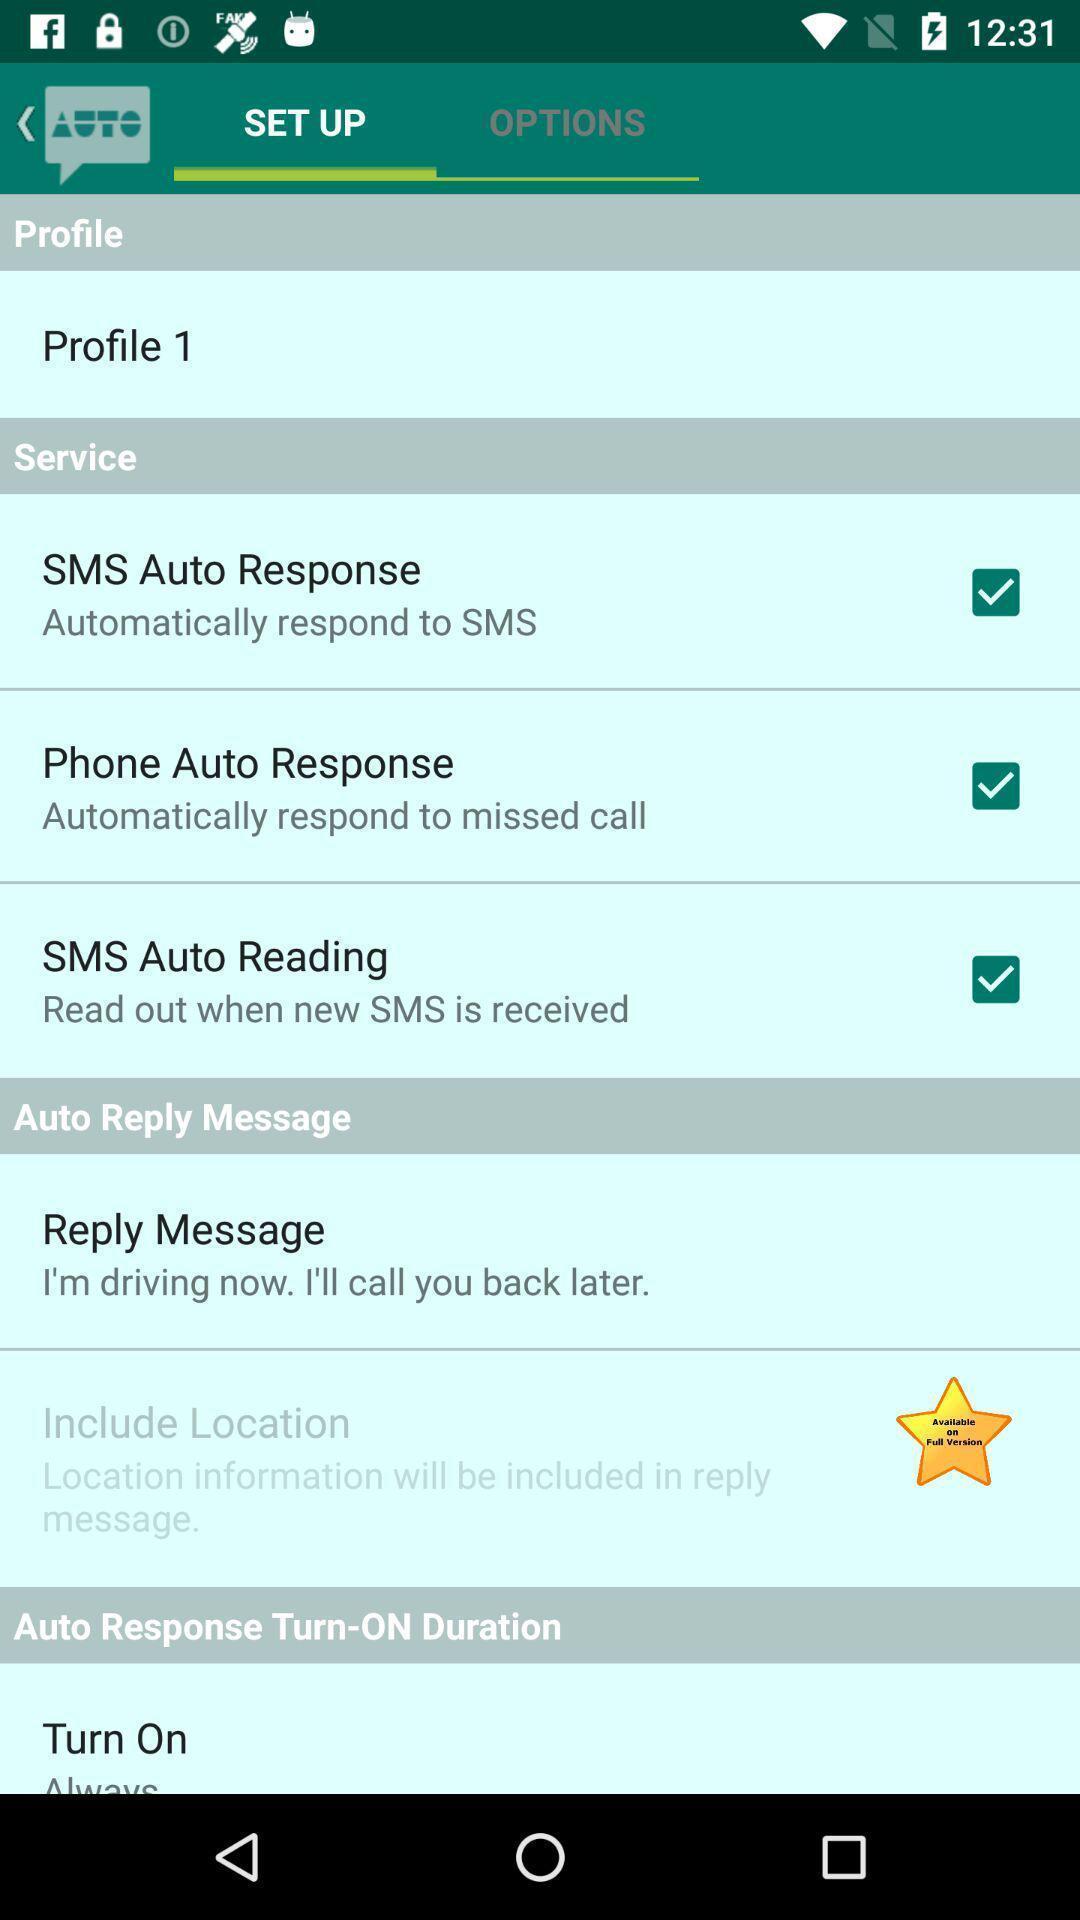What details can you identify in this image? Page displaying with setting options for the profile. 